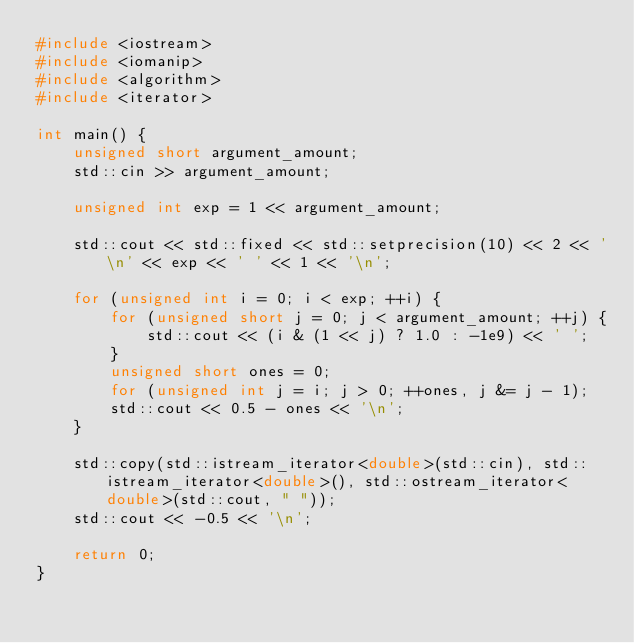<code> <loc_0><loc_0><loc_500><loc_500><_C++_>#include <iostream>
#include <iomanip>
#include <algorithm>
#include <iterator>

int main() {
    unsigned short argument_amount;
    std::cin >> argument_amount;

    unsigned int exp = 1 << argument_amount;

    std::cout << std::fixed << std::setprecision(10) << 2 << '\n' << exp << ' ' << 1 << '\n';

    for (unsigned int i = 0; i < exp; ++i) {
        for (unsigned short j = 0; j < argument_amount; ++j) {
            std::cout << (i & (1 << j) ? 1.0 : -1e9) << ' ';
        }
        unsigned short ones = 0;
        for (unsigned int j = i; j > 0; ++ones, j &= j - 1);
        std::cout << 0.5 - ones << '\n';
    }

    std::copy(std::istream_iterator<double>(std::cin), std::istream_iterator<double>(), std::ostream_iterator<double>(std::cout, " "));
    std::cout << -0.5 << '\n';

    return 0;
}
</code> 